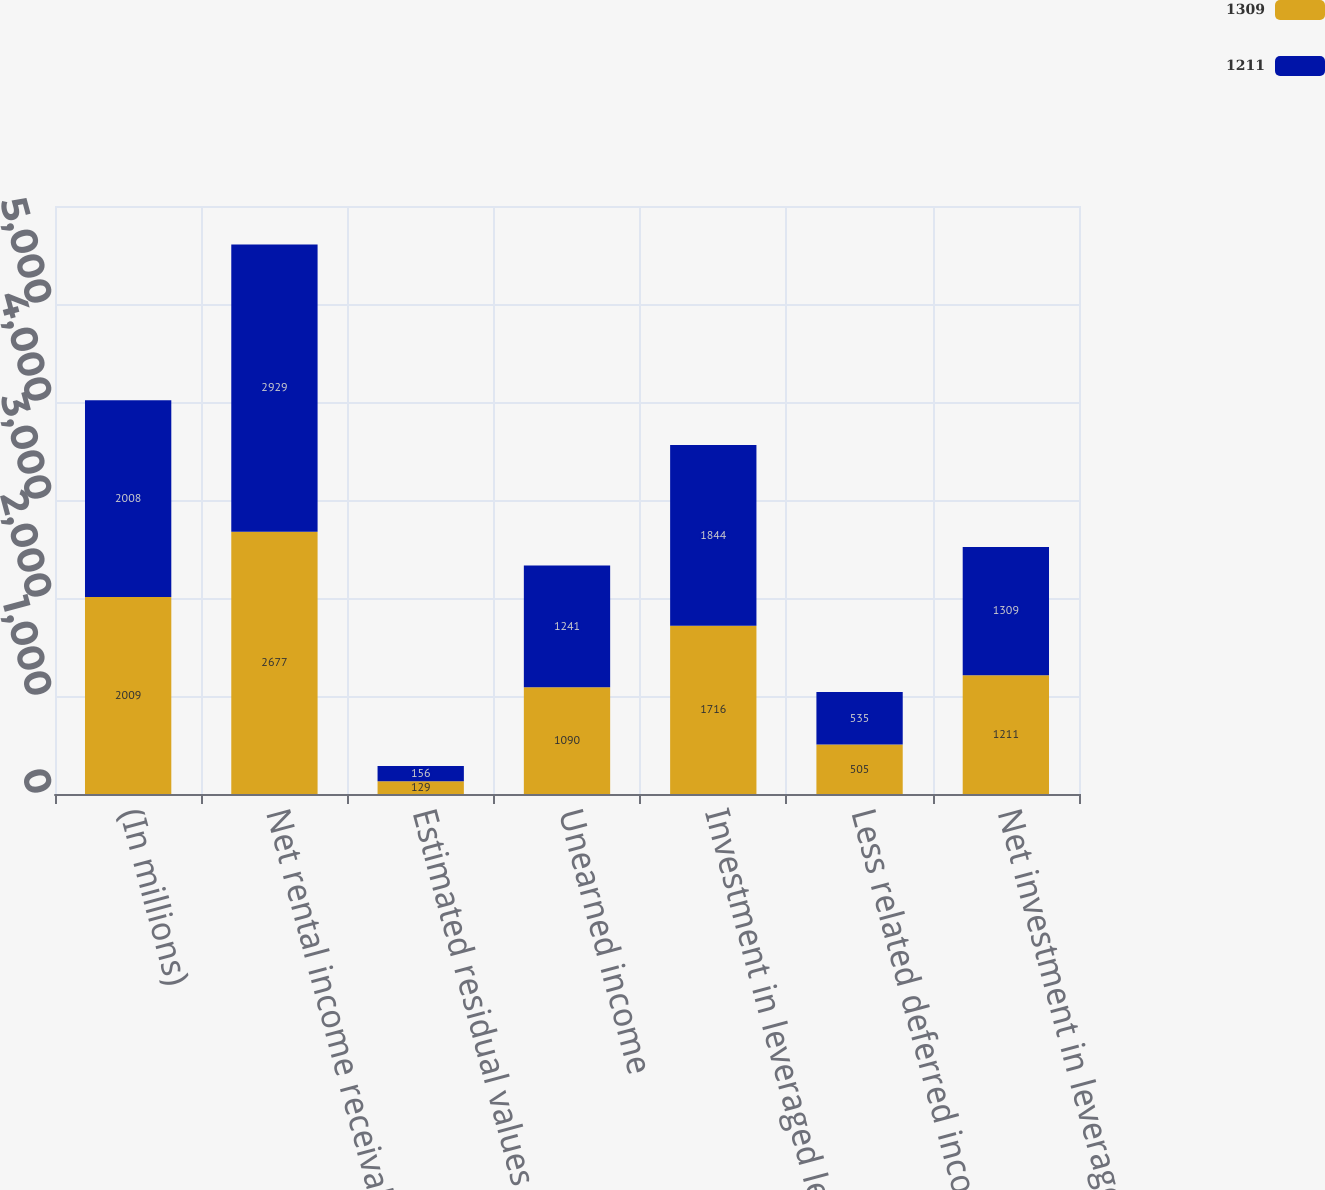<chart> <loc_0><loc_0><loc_500><loc_500><stacked_bar_chart><ecel><fcel>(In millions)<fcel>Net rental income receivable<fcel>Estimated residual values<fcel>Unearned income<fcel>Investment in leveraged leases<fcel>Less related deferred income<fcel>Net investment in leveraged<nl><fcel>1309<fcel>2009<fcel>2677<fcel>129<fcel>1090<fcel>1716<fcel>505<fcel>1211<nl><fcel>1211<fcel>2008<fcel>2929<fcel>156<fcel>1241<fcel>1844<fcel>535<fcel>1309<nl></chart> 